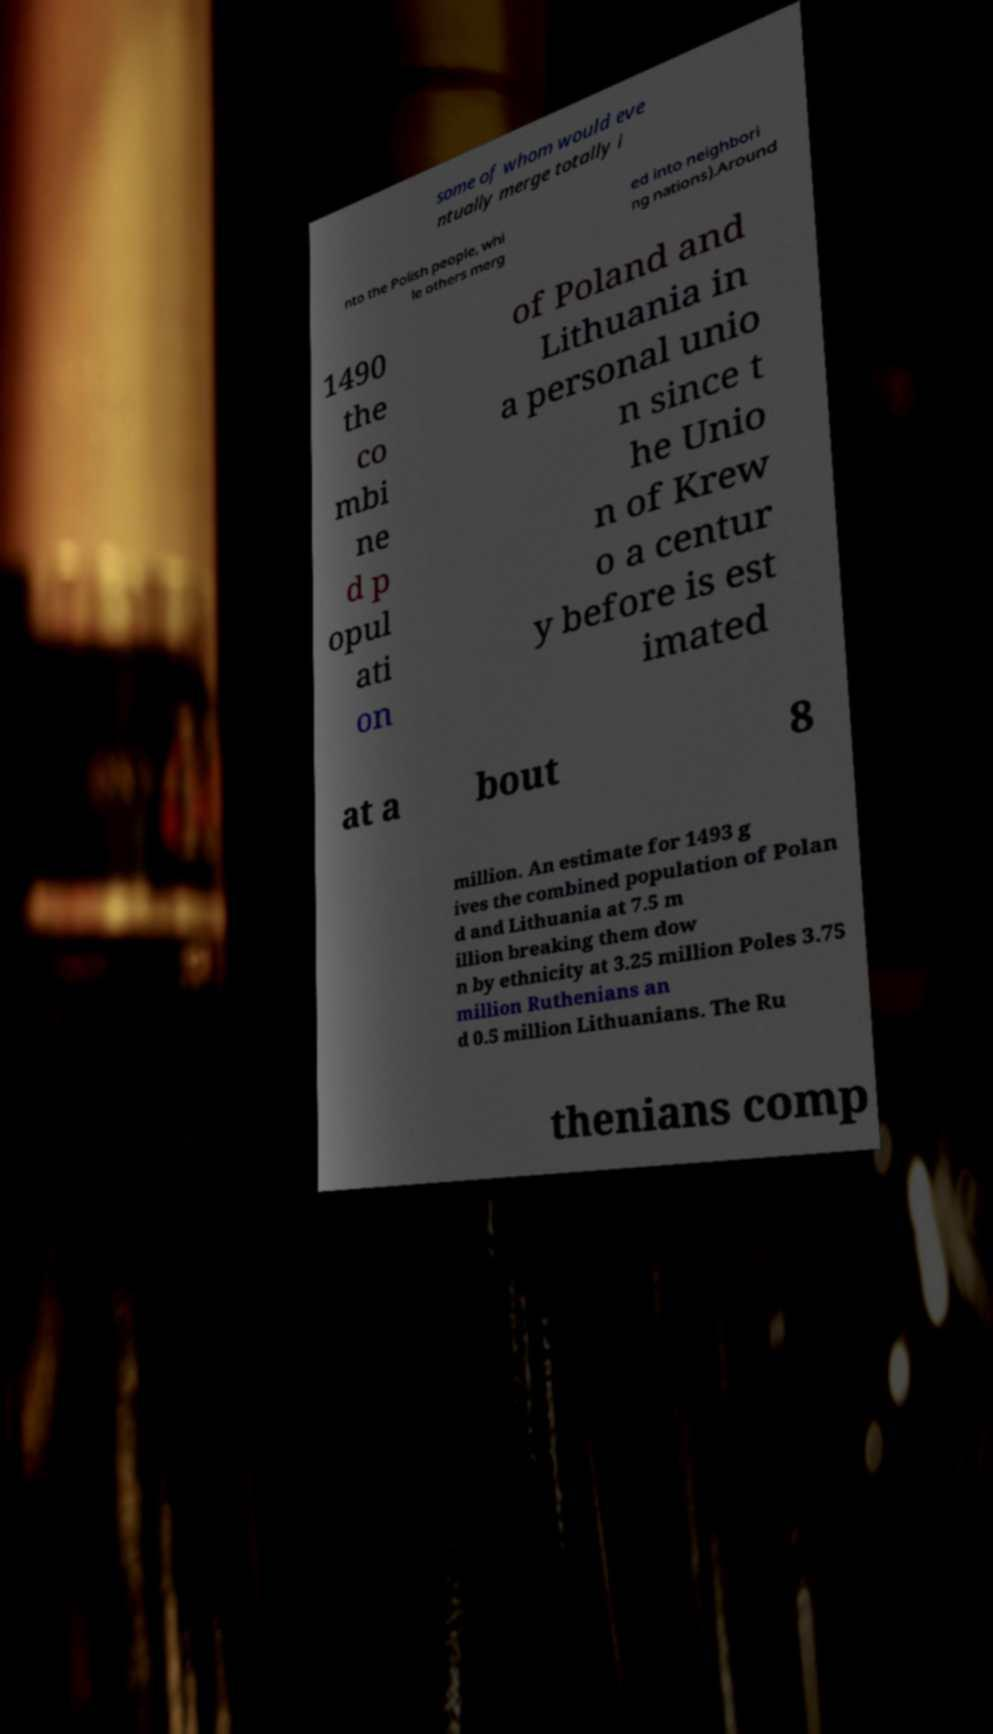What messages or text are displayed in this image? I need them in a readable, typed format. some of whom would eve ntually merge totally i nto the Polish people, whi le others merg ed into neighbori ng nations).Around 1490 the co mbi ne d p opul ati on of Poland and Lithuania in a personal unio n since t he Unio n of Krew o a centur y before is est imated at a bout 8 million. An estimate for 1493 g ives the combined population of Polan d and Lithuania at 7.5 m illion breaking them dow n by ethnicity at 3.25 million Poles 3.75 million Ruthenians an d 0.5 million Lithuanians. The Ru thenians comp 